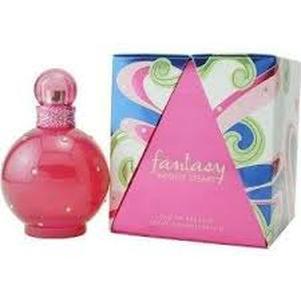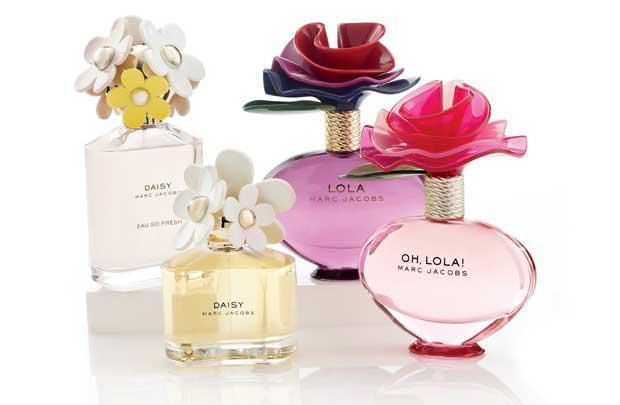The first image is the image on the left, the second image is the image on the right. Assess this claim about the two images: "One image includes a single perfume bottle, which has a pink non-square top.". Correct or not? Answer yes or no. Yes. The first image is the image on the left, the second image is the image on the right. Analyze the images presented: Is the assertion "In one of the images, there is a single bottle of perfume and it is pink." valid? Answer yes or no. Yes. 